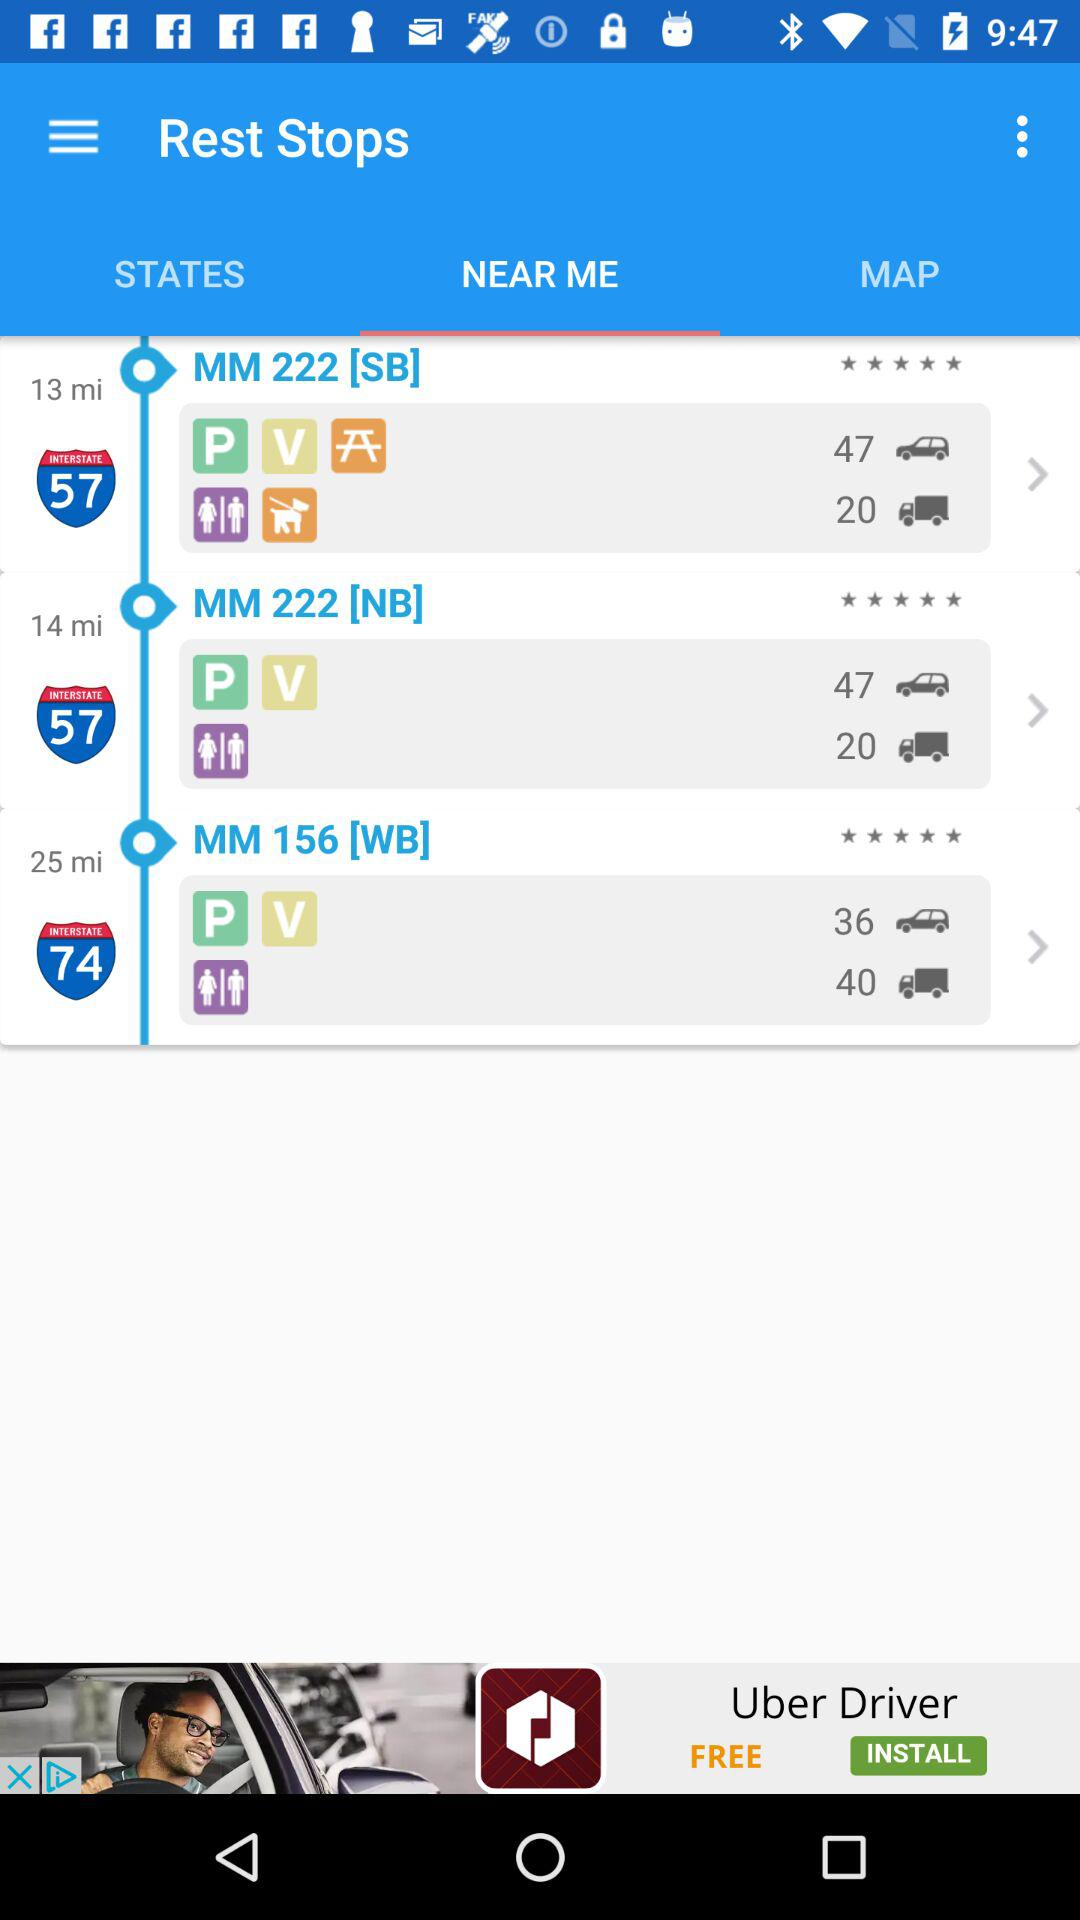Which tab has been selected? The tab "NEAR ME" has been selected. 